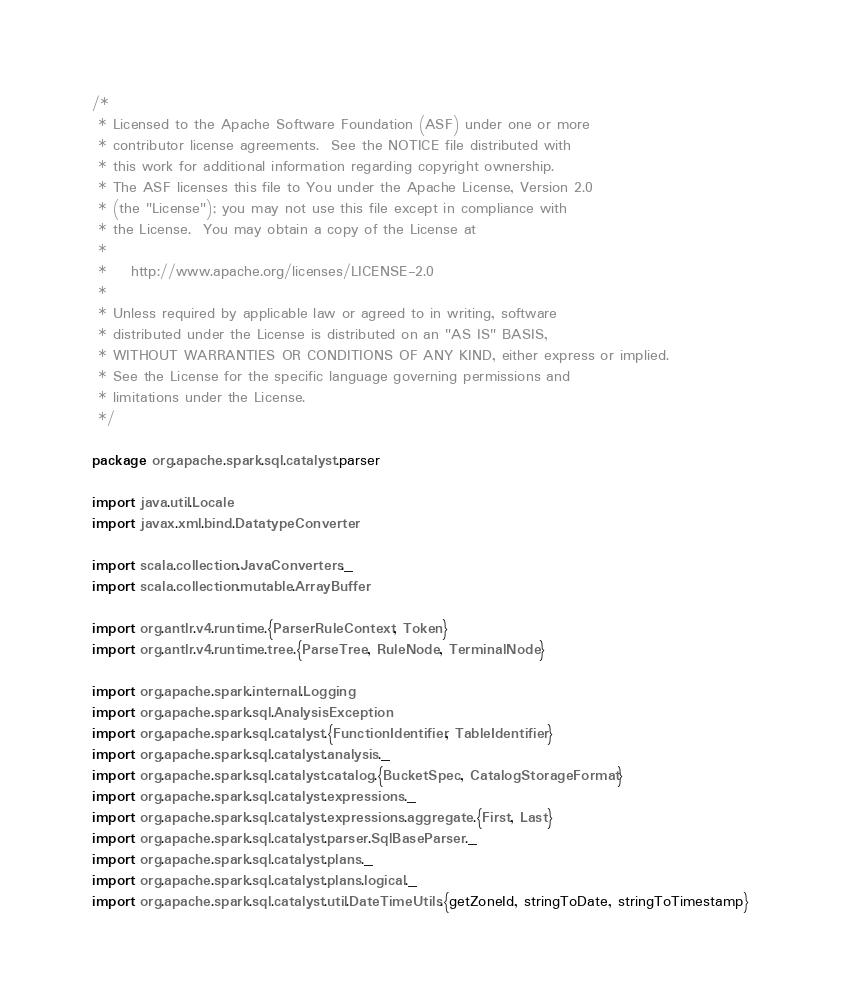Convert code to text. <code><loc_0><loc_0><loc_500><loc_500><_Scala_>/*
 * Licensed to the Apache Software Foundation (ASF) under one or more
 * contributor license agreements.  See the NOTICE file distributed with
 * this work for additional information regarding copyright ownership.
 * The ASF licenses this file to You under the Apache License, Version 2.0
 * (the "License"); you may not use this file except in compliance with
 * the License.  You may obtain a copy of the License at
 *
 *    http://www.apache.org/licenses/LICENSE-2.0
 *
 * Unless required by applicable law or agreed to in writing, software
 * distributed under the License is distributed on an "AS IS" BASIS,
 * WITHOUT WARRANTIES OR CONDITIONS OF ANY KIND, either express or implied.
 * See the License for the specific language governing permissions and
 * limitations under the License.
 */

package org.apache.spark.sql.catalyst.parser

import java.util.Locale
import javax.xml.bind.DatatypeConverter

import scala.collection.JavaConverters._
import scala.collection.mutable.ArrayBuffer

import org.antlr.v4.runtime.{ParserRuleContext, Token}
import org.antlr.v4.runtime.tree.{ParseTree, RuleNode, TerminalNode}

import org.apache.spark.internal.Logging
import org.apache.spark.sql.AnalysisException
import org.apache.spark.sql.catalyst.{FunctionIdentifier, TableIdentifier}
import org.apache.spark.sql.catalyst.analysis._
import org.apache.spark.sql.catalyst.catalog.{BucketSpec, CatalogStorageFormat}
import org.apache.spark.sql.catalyst.expressions._
import org.apache.spark.sql.catalyst.expressions.aggregate.{First, Last}
import org.apache.spark.sql.catalyst.parser.SqlBaseParser._
import org.apache.spark.sql.catalyst.plans._
import org.apache.spark.sql.catalyst.plans.logical._
import org.apache.spark.sql.catalyst.util.DateTimeUtils.{getZoneId, stringToDate, stringToTimestamp}</code> 